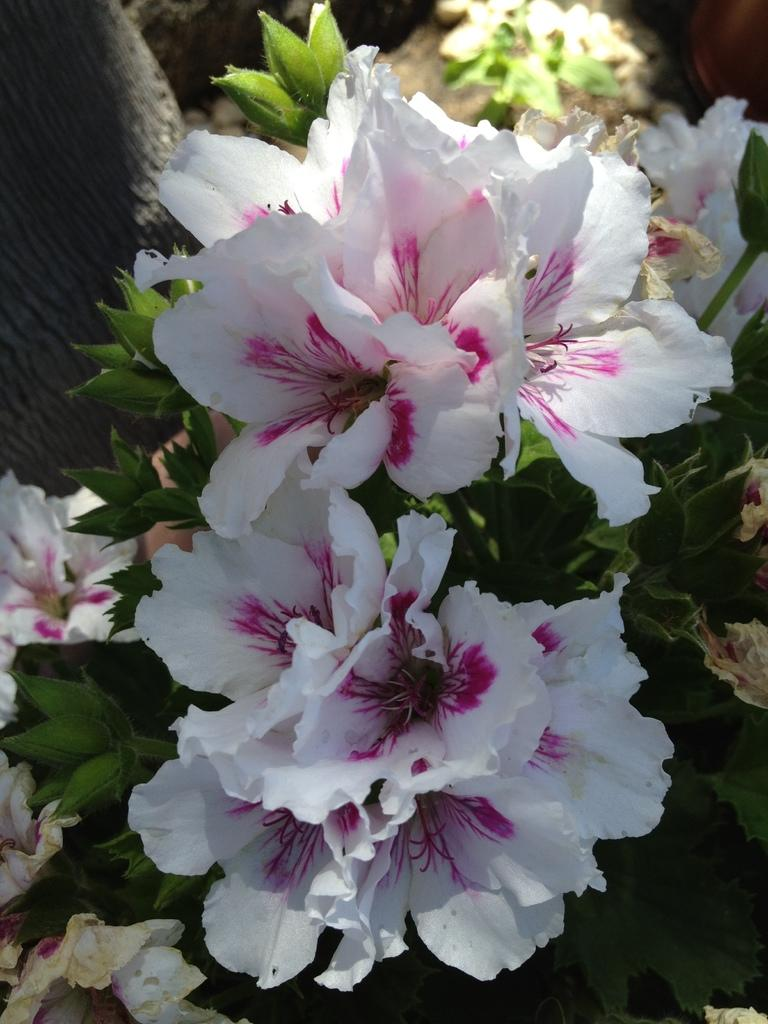What type of plants can be seen in the image? There are plants with flowers in the image. Can you describe any other elements in the background of the image? There is a tree trunk visible in the background of the image. How many jellyfish are swimming near the tree trunk in the image? There are no jellyfish present in the image; it features plants with flowers and a tree trunk. Can you describe the cooking skills of the plants in the image? The plants in the image do not possess cooking skills, as they are not living beings capable of such activities. 